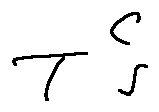<formula> <loc_0><loc_0><loc_500><loc_500>T ^ { C } s</formula> 